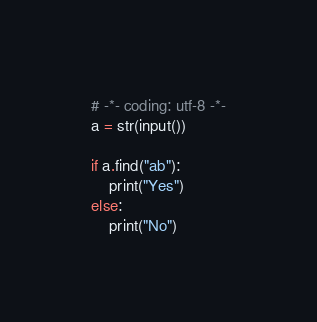<code> <loc_0><loc_0><loc_500><loc_500><_Python_># -*- coding: utf-8 -*-
a = str(input())

if a.find("ab"):
	print("Yes")
else:
	print("No")</code> 